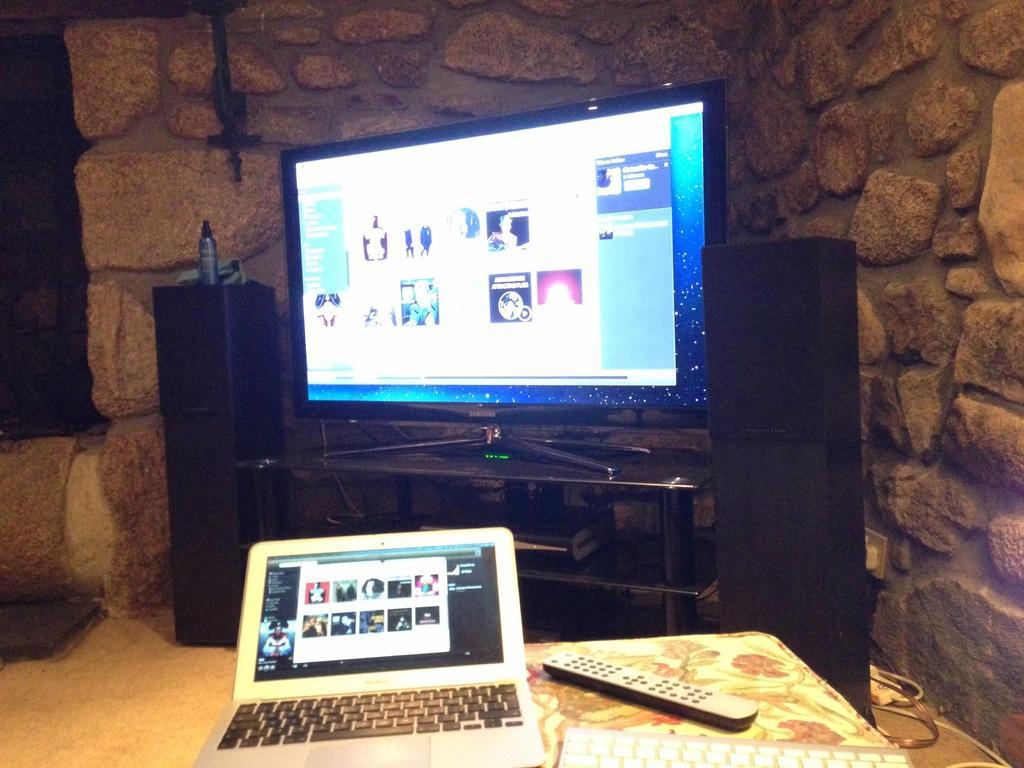Could you give a brief overview of what you see in this image? In this picture I can see a laptop, remote, keyboard, speakers, there is a television on the table, and in the background there is a wall. 